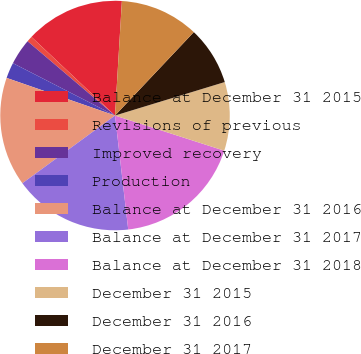<chart> <loc_0><loc_0><loc_500><loc_500><pie_chart><fcel>Balance at December 31 2015<fcel>Revisions of previous<fcel>Improved recovery<fcel>Production<fcel>Balance at December 31 2016<fcel>Balance at December 31 2017<fcel>Balance at December 31 2018<fcel>December 31 2015<fcel>December 31 2016<fcel>December 31 2017<nl><fcel>13.94%<fcel>0.81%<fcel>3.66%<fcel>2.23%<fcel>15.36%<fcel>16.79%<fcel>18.21%<fcel>9.67%<fcel>8.24%<fcel>11.09%<nl></chart> 